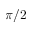<formula> <loc_0><loc_0><loc_500><loc_500>\pi / 2</formula> 